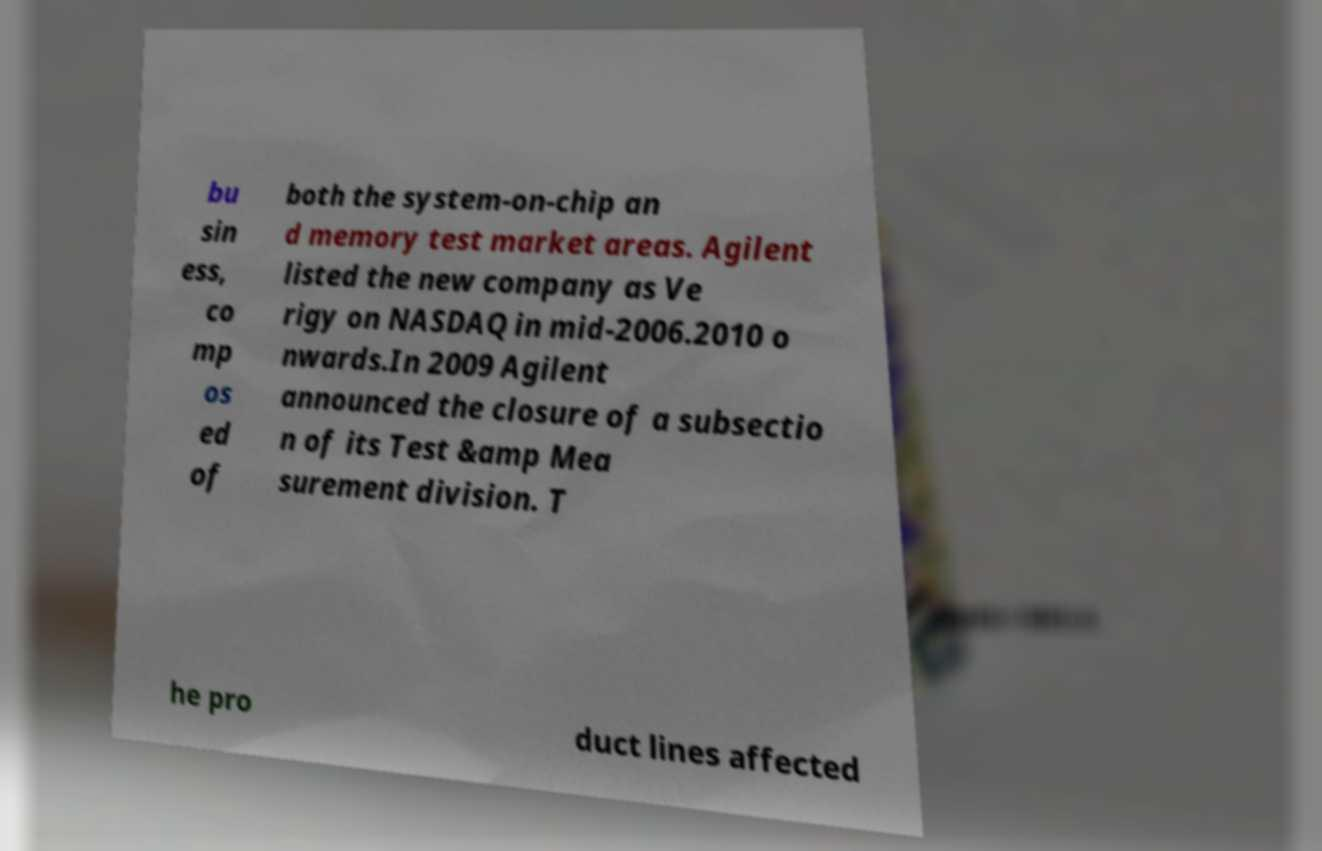Can you accurately transcribe the text from the provided image for me? bu sin ess, co mp os ed of both the system-on-chip an d memory test market areas. Agilent listed the new company as Ve rigy on NASDAQ in mid-2006.2010 o nwards.In 2009 Agilent announced the closure of a subsectio n of its Test &amp Mea surement division. T he pro duct lines affected 